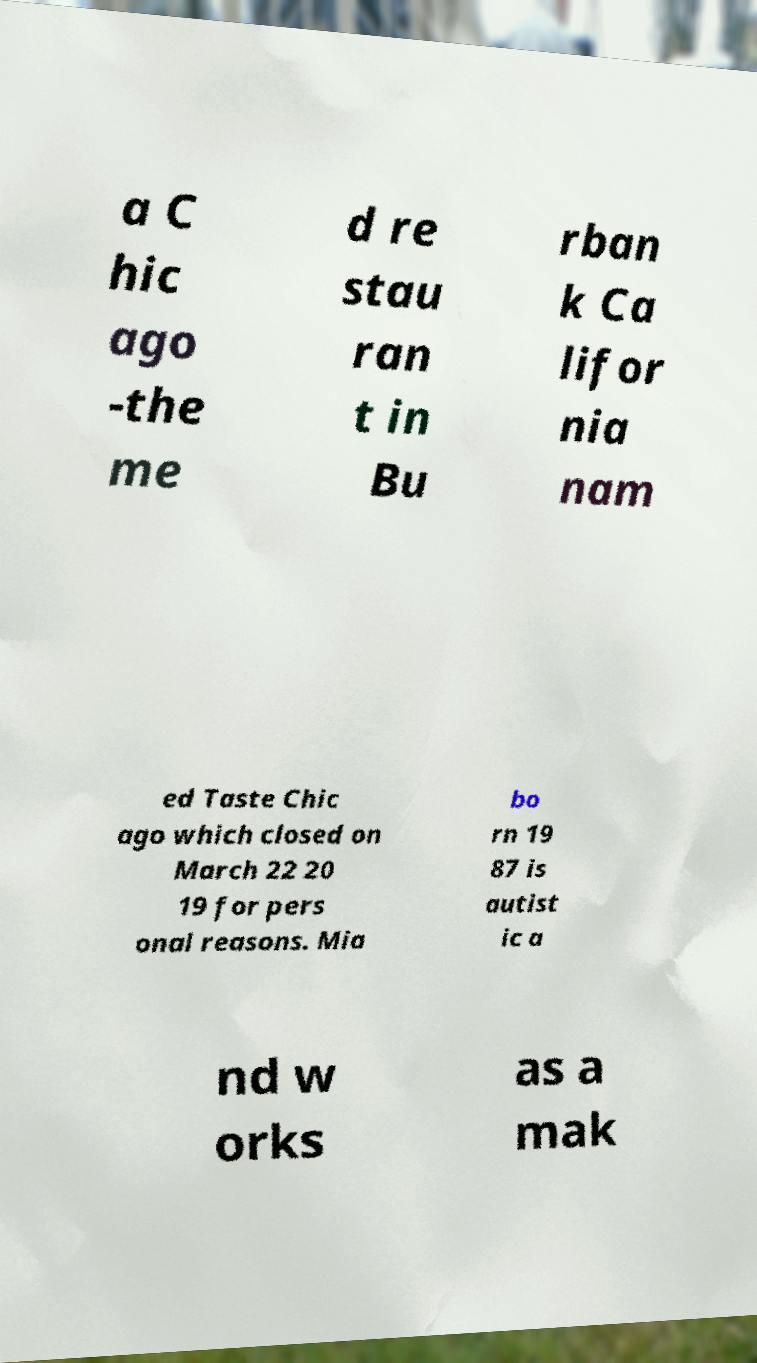Please identify and transcribe the text found in this image. a C hic ago -the me d re stau ran t in Bu rban k Ca lifor nia nam ed Taste Chic ago which closed on March 22 20 19 for pers onal reasons. Mia bo rn 19 87 is autist ic a nd w orks as a mak 